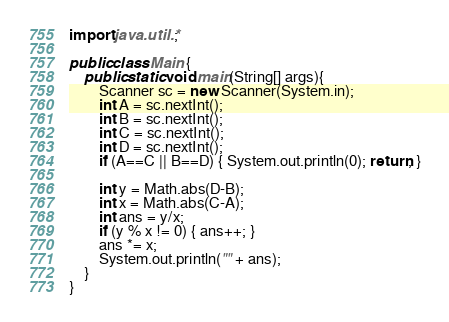Convert code to text. <code><loc_0><loc_0><loc_500><loc_500><_Java_>import java.util.*;

public class Main {
    public static void main(String[] args){
        Scanner sc = new Scanner(System.in);
        int A = sc.nextInt();
        int B = sc.nextInt();
        int C = sc.nextInt();
        int D = sc.nextInt();
        if (A==C || B==D) { System.out.println(0); return; }

        int y = Math.abs(D-B);
        int x = Math.abs(C-A);
        int ans = y/x;
        if (y % x != 0) { ans++; }
        ans *= x;
        System.out.println("" + ans);
    }
}
</code> 